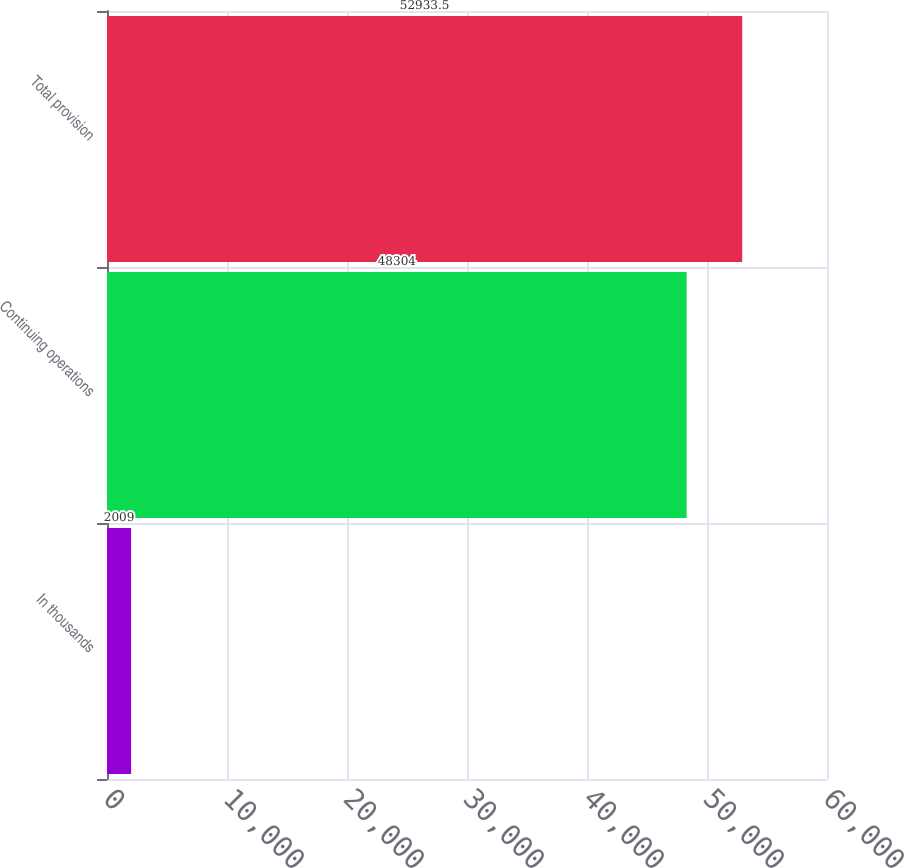<chart> <loc_0><loc_0><loc_500><loc_500><bar_chart><fcel>In thousands<fcel>Continuing operations<fcel>Total provision<nl><fcel>2009<fcel>48304<fcel>52933.5<nl></chart> 